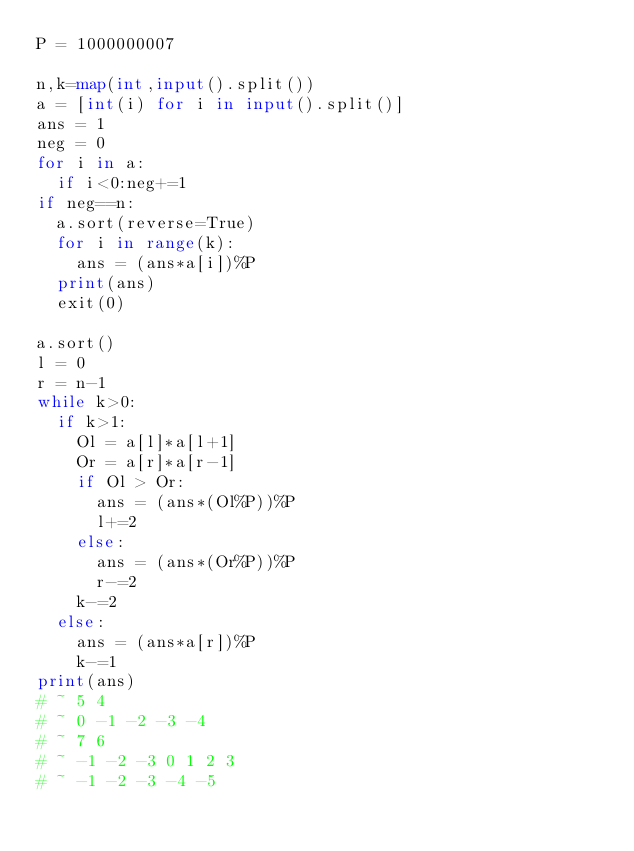Convert code to text. <code><loc_0><loc_0><loc_500><loc_500><_Python_>P = 1000000007

n,k=map(int,input().split())
a = [int(i) for i in input().split()]
ans = 1
neg = 0
for i in a:
	if i<0:neg+=1
if neg==n:
	a.sort(reverse=True)
	for i in range(k):
		ans = (ans*a[i])%P
	print(ans)
	exit(0)

a.sort()
l = 0
r = n-1
while k>0:
	if k>1:
		Ol = a[l]*a[l+1]
		Or = a[r]*a[r-1]
		if Ol > Or:
			ans = (ans*(Ol%P))%P
			l+=2
		else:
			ans = (ans*(Or%P))%P
			r-=2
		k-=2
	else:
		ans = (ans*a[r])%P
		k-=1
print(ans)
# ~ 5 4
# ~ 0 -1 -2 -3 -4
# ~ 7 6
# ~ -1 -2 -3 0 1 2 3
# ~ -1 -2 -3 -4 -5
</code> 